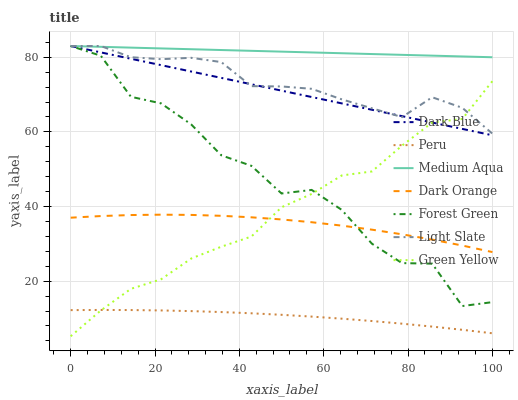Does Peru have the minimum area under the curve?
Answer yes or no. Yes. Does Medium Aqua have the maximum area under the curve?
Answer yes or no. Yes. Does Light Slate have the minimum area under the curve?
Answer yes or no. No. Does Light Slate have the maximum area under the curve?
Answer yes or no. No. Is Medium Aqua the smoothest?
Answer yes or no. Yes. Is Forest Green the roughest?
Answer yes or no. Yes. Is Light Slate the smoothest?
Answer yes or no. No. Is Light Slate the roughest?
Answer yes or no. No. Does Green Yellow have the lowest value?
Answer yes or no. Yes. Does Light Slate have the lowest value?
Answer yes or no. No. Does Medium Aqua have the highest value?
Answer yes or no. Yes. Does Peru have the highest value?
Answer yes or no. No. Is Dark Orange less than Light Slate?
Answer yes or no. Yes. Is Light Slate greater than Peru?
Answer yes or no. Yes. Does Green Yellow intersect Peru?
Answer yes or no. Yes. Is Green Yellow less than Peru?
Answer yes or no. No. Is Green Yellow greater than Peru?
Answer yes or no. No. Does Dark Orange intersect Light Slate?
Answer yes or no. No. 